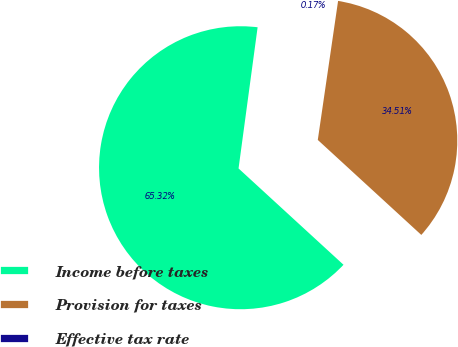Convert chart. <chart><loc_0><loc_0><loc_500><loc_500><pie_chart><fcel>Income before taxes<fcel>Provision for taxes<fcel>Effective tax rate<nl><fcel>65.32%<fcel>34.51%<fcel>0.17%<nl></chart> 